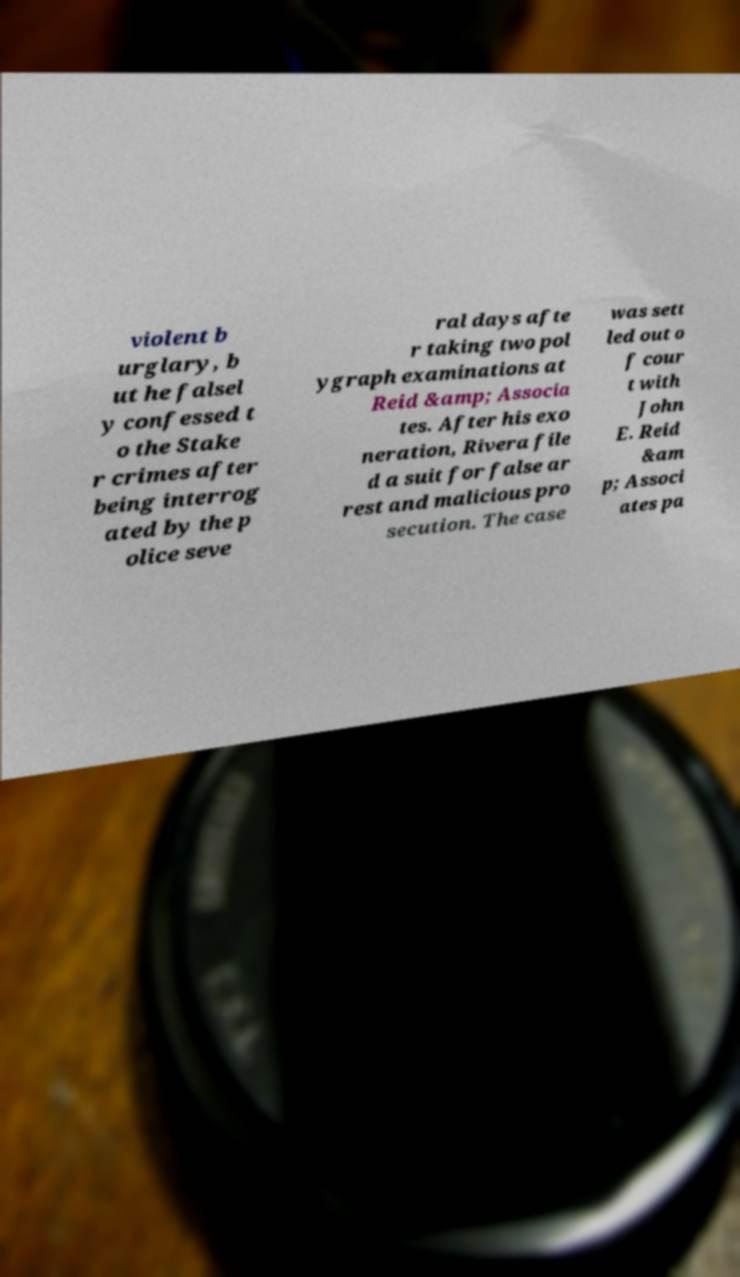I need the written content from this picture converted into text. Can you do that? violent b urglary, b ut he falsel y confessed t o the Stake r crimes after being interrog ated by the p olice seve ral days afte r taking two pol ygraph examinations at Reid &amp; Associa tes. After his exo neration, Rivera file d a suit for false ar rest and malicious pro secution. The case was sett led out o f cour t with John E. Reid &am p; Associ ates pa 